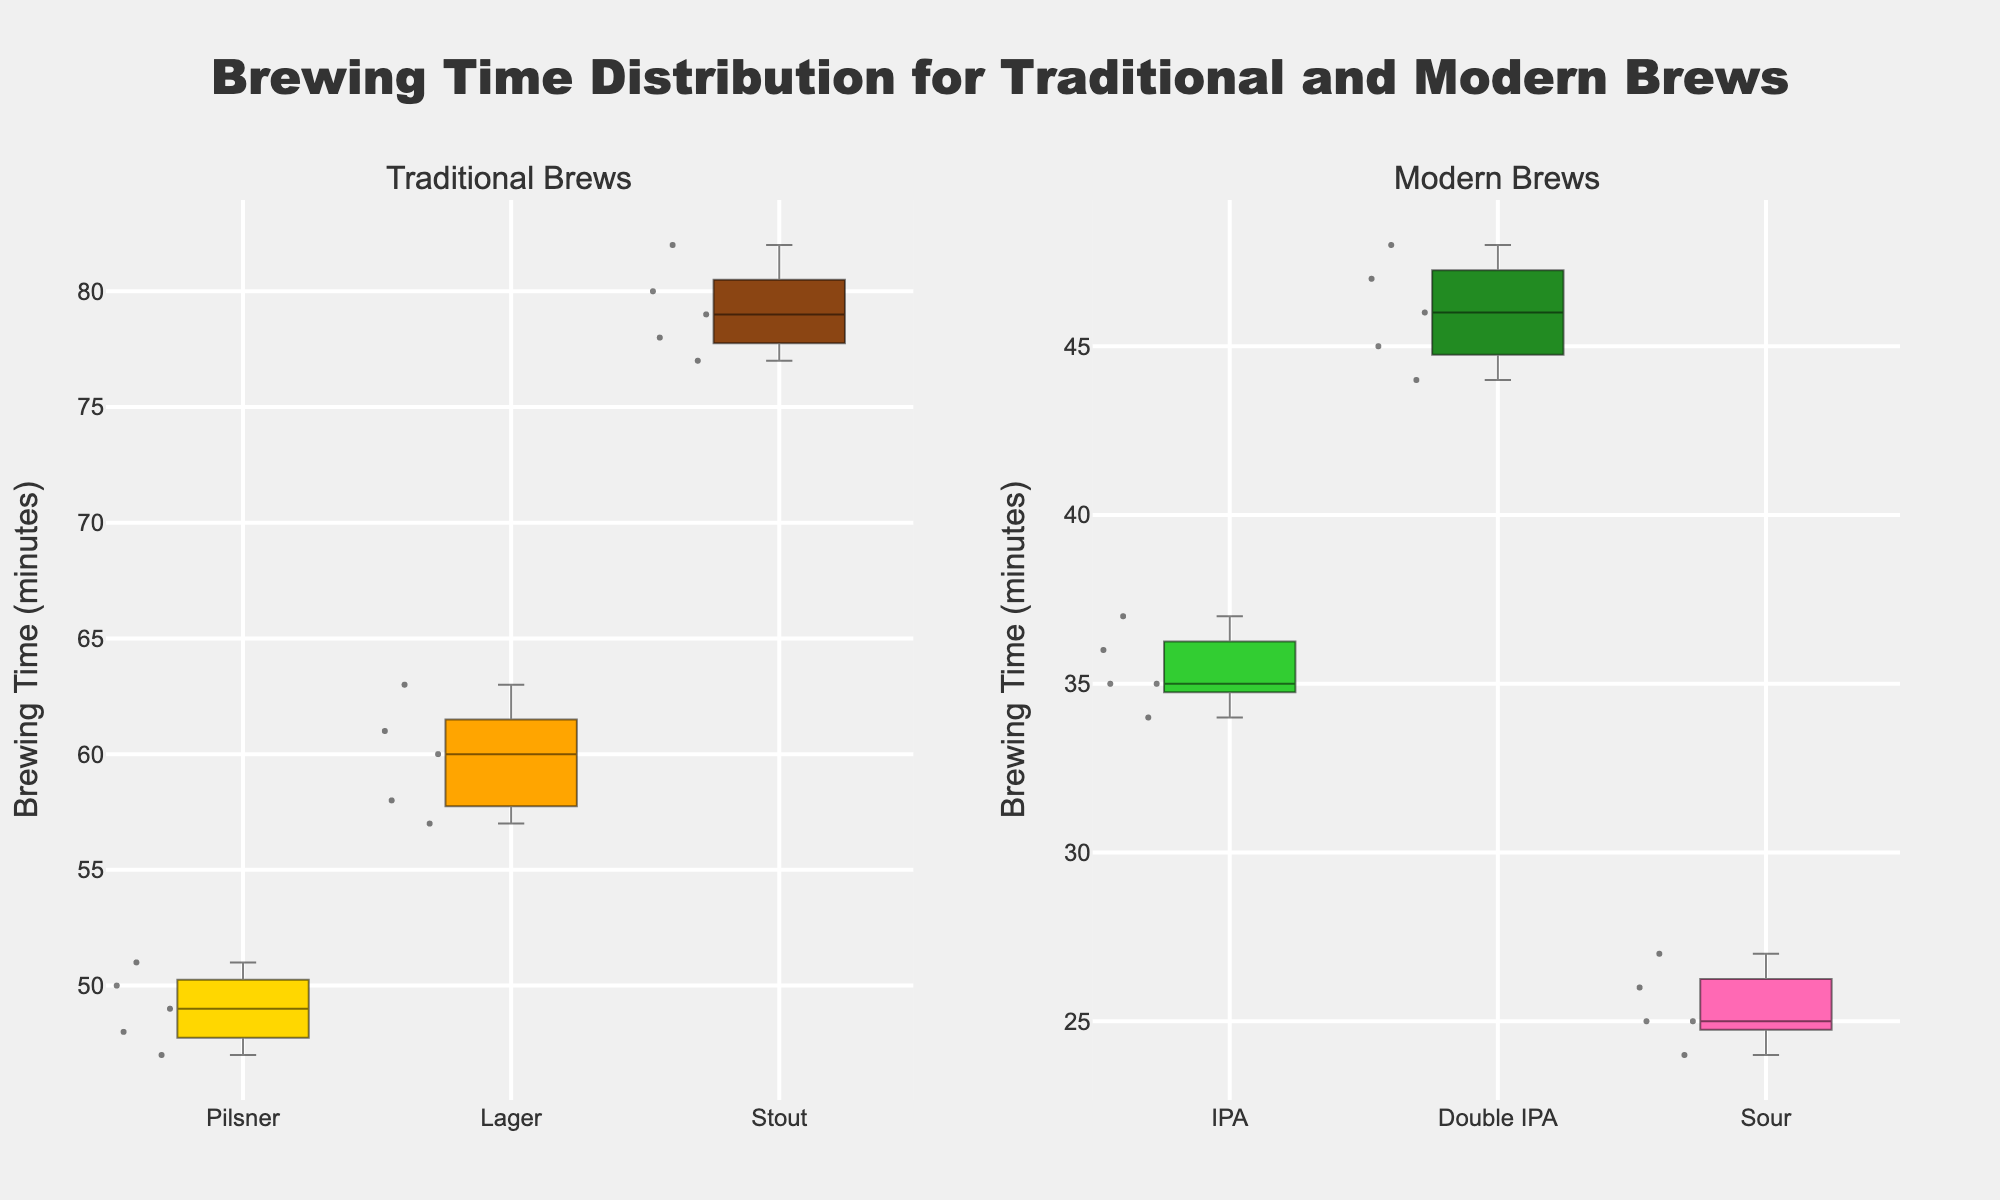What are the titles of the subplots? The titles are displayed above each subplot. For Traditional brews, the title is "Traditional Brews"; for Modern brews, the title is "Modern Brews".
Answer: Traditional Brews; Modern Brews Which brew has the widest range of brewing times? The range can be identified by looking at the length of the whiskers in the box plots. The traditional brew Stout has the widest range from about 77 to 82.
Answer: Stout What is the median brewing time for Sour? The median can be identified by the line inside the box. For Sour, it is around 25.
Answer: 25 Which brew, Pilsner or IPA, has the lower median brewing time? The median time is displayed as a line inside the box plot. Comparing Pilsner and IPA, IPA has a median brewing time of around 35, while Pilsner has around 49. Therefore, IPA has a lower median.
Answer: IPA Among the traditional brews, which one has the highest maximum brewing time? The maximum brewing time can be identified by the top whisker of the box plot. Among traditional brews, Stout has the highest maximum brewing time of around 82 minutes.
Answer: Stout What is the interquartile range (IQR) for Lager? The IQR is the difference between the third quartile (Q3) and the first quartile (Q1). For Lager, Q3 is around 61 and Q1 is around 58. So, the IQR is 61 - 58 = 3.
Answer: 3 Are there any overlapping interquartile ranges in Modern brews? Overlapping IQRs indicate that the boxes in the box plots overlap. For Modern brews, the IQRs of IPA, Double IPA, and Sour do not overlap.
Answer: No Which Traditional brew has the smallest IQR? The smallest IQR is identified by the smallest box. Among traditional brews, Pilsner has the smallest IQR.
Answer: Pilsner What is the median brewing time difference between Lager and Double IPA? The median for Lager is around 60, and for Double IPA, it is around 46. The difference is 60 - 46 = 14.
Answer: 14 How does the brewing time distribution for Modern brews compare to Traditional brews in terms of variability? Comparing the range and spread of the box plots, Traditional brews (especially Stout and Lager with wider ranges) have higher variability compared to Modern brews.
Answer: Traditional brews have higher variability 